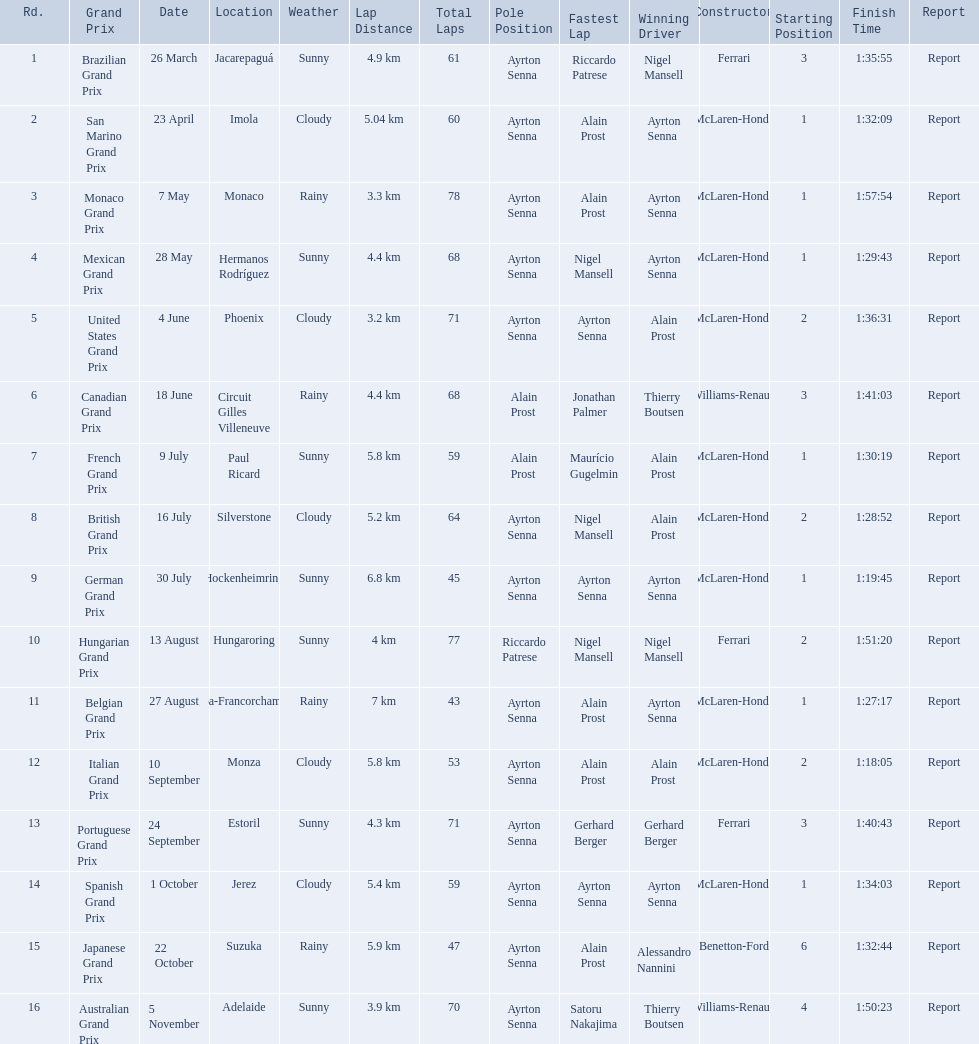Who won the spanish grand prix? McLaren-Honda. Who won the italian grand prix? McLaren-Honda. What grand prix did benneton-ford win? Japanese Grand Prix. 